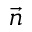<formula> <loc_0><loc_0><loc_500><loc_500>\vec { n }</formula> 